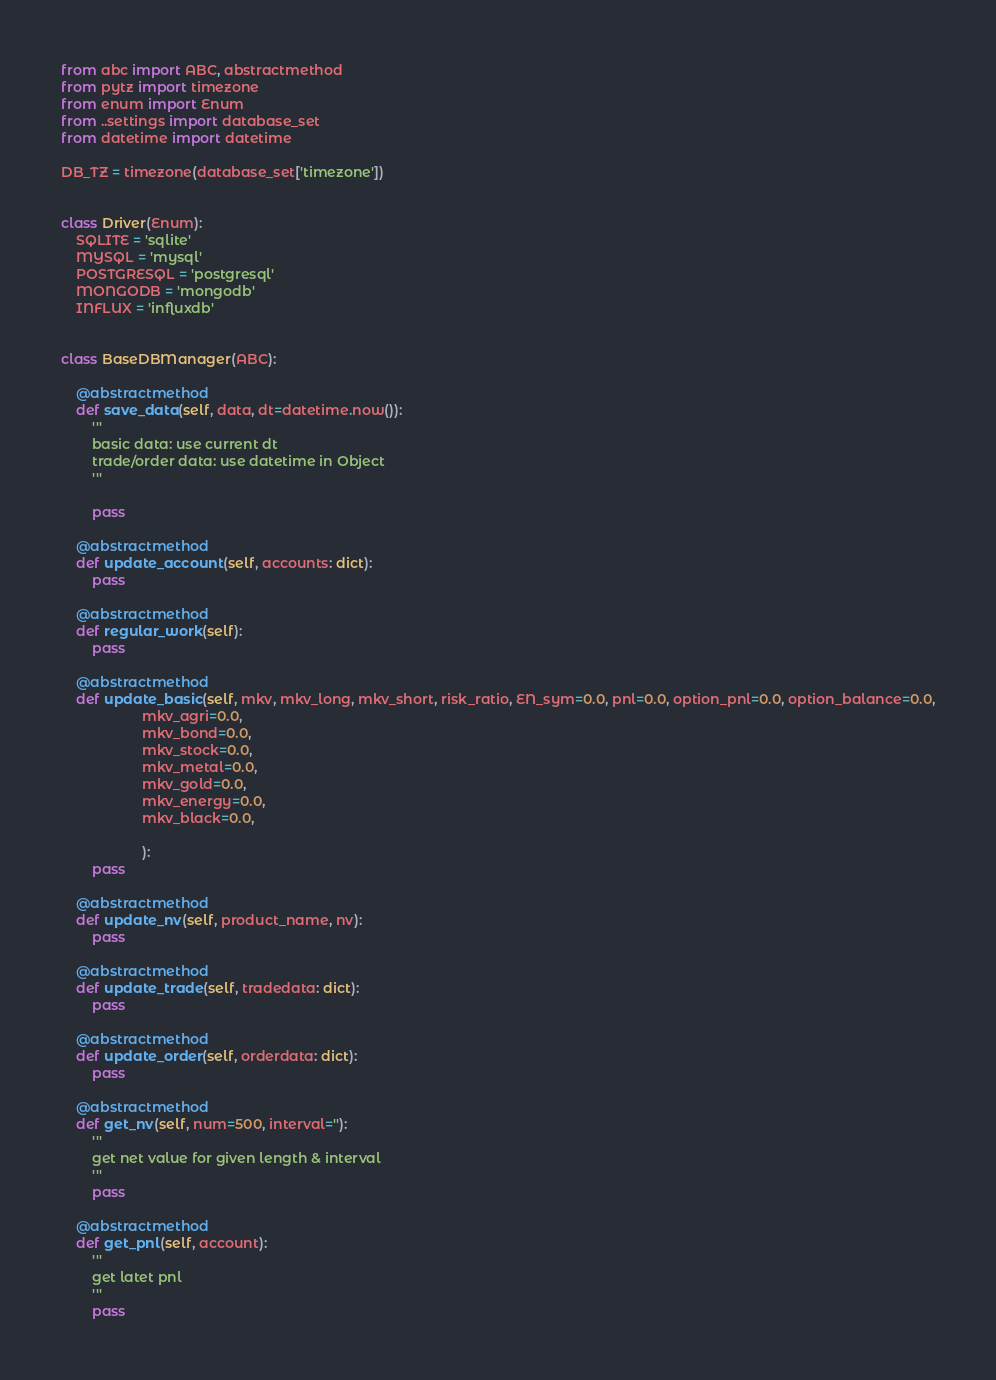Convert code to text. <code><loc_0><loc_0><loc_500><loc_500><_Python_>from abc import ABC, abstractmethod
from pytz import timezone
from enum import Enum
from ..settings import database_set
from datetime import datetime

DB_TZ = timezone(database_set['timezone'])


class Driver(Enum):
    SQLITE = 'sqlite'
    MYSQL = 'mysql'
    POSTGRESQL = 'postgresql'
    MONGODB = 'mongodb'
    INFLUX = 'influxdb'


class BaseDBManager(ABC):

    @abstractmethod
    def save_data(self, data, dt=datetime.now()):
        '''
        basic data: use current dt
        trade/order data: use datetime in Object
        '''

        pass

    @abstractmethod
    def update_account(self, accounts: dict):
        pass

    @abstractmethod
    def regular_work(self):
        pass

    @abstractmethod
    def update_basic(self, mkv, mkv_long, mkv_short, risk_ratio, EN_sym=0.0, pnl=0.0, option_pnl=0.0, option_balance=0.0,
                     mkv_agri=0.0,
                     mkv_bond=0.0,
                     mkv_stock=0.0,
                     mkv_metal=0.0,
                     mkv_gold=0.0,
                     mkv_energy=0.0,
                     mkv_black=0.0,

                     ):
        pass

    @abstractmethod
    def update_nv(self, product_name, nv):
        pass

    @abstractmethod
    def update_trade(self, tradedata: dict):
        pass

    @abstractmethod
    def update_order(self, orderdata: dict):
        pass

    @abstractmethod
    def get_nv(self, num=500, interval=''):
        '''
        get net value for given length & interval
        '''
        pass

    @abstractmethod
    def get_pnl(self, account):
        '''
        get latet pnl
        '''
        pass

</code> 